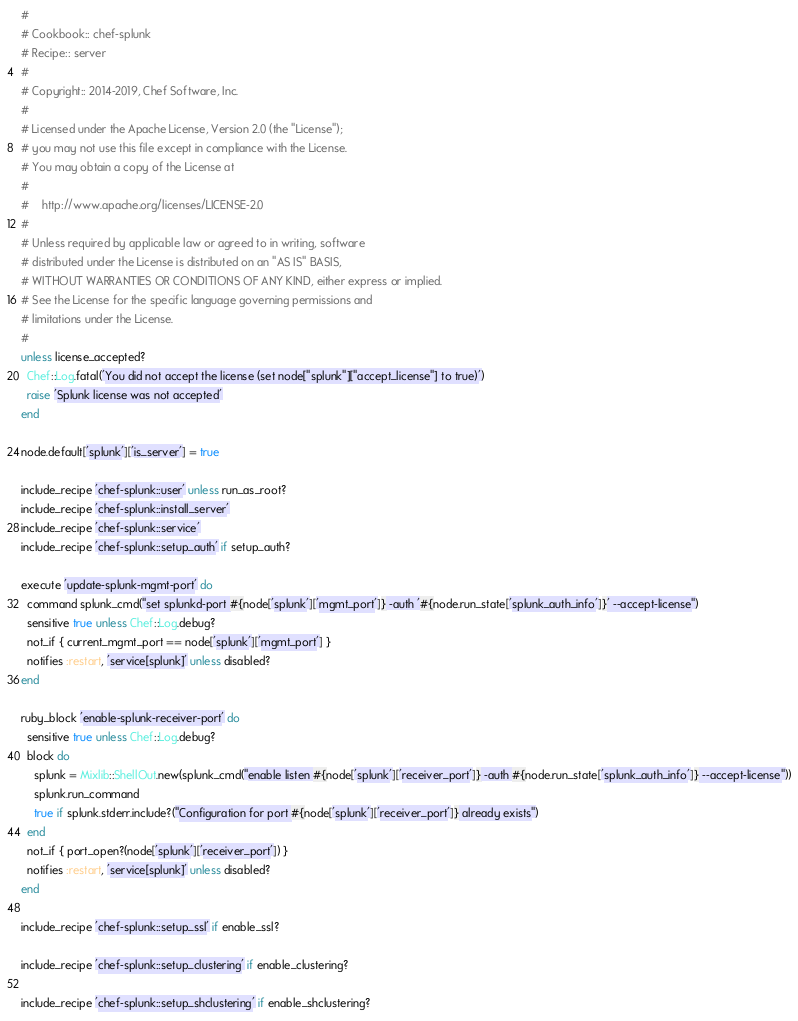Convert code to text. <code><loc_0><loc_0><loc_500><loc_500><_Ruby_>#
# Cookbook:: chef-splunk
# Recipe:: server
#
# Copyright:: 2014-2019, Chef Software, Inc.
#
# Licensed under the Apache License, Version 2.0 (the "License");
# you may not use this file except in compliance with the License.
# You may obtain a copy of the License at
#
#    http://www.apache.org/licenses/LICENSE-2.0
#
# Unless required by applicable law or agreed to in writing, software
# distributed under the License is distributed on an "AS IS" BASIS,
# WITHOUT WARRANTIES OR CONDITIONS OF ANY KIND, either express or implied.
# See the License for the specific language governing permissions and
# limitations under the License.
#
unless license_accepted?
  Chef::Log.fatal('You did not accept the license (set node["splunk"]["accept_license"] to true)')
  raise 'Splunk license was not accepted'
end

node.default['splunk']['is_server'] = true

include_recipe 'chef-splunk::user' unless run_as_root?
include_recipe 'chef-splunk::install_server'
include_recipe 'chef-splunk::service'
include_recipe 'chef-splunk::setup_auth' if setup_auth?

execute 'update-splunk-mgmt-port' do
  command splunk_cmd("set splunkd-port #{node['splunk']['mgmt_port']} -auth '#{node.run_state['splunk_auth_info']}' --accept-license")
  sensitive true unless Chef::Log.debug?
  not_if { current_mgmt_port == node['splunk']['mgmt_port'] }
  notifies :restart, 'service[splunk]' unless disabled?
end

ruby_block 'enable-splunk-receiver-port' do
  sensitive true unless Chef::Log.debug?
  block do
    splunk = Mixlib::ShellOut.new(splunk_cmd("enable listen #{node['splunk']['receiver_port']} -auth #{node.run_state['splunk_auth_info']} --accept-license"))
    splunk.run_command
    true if splunk.stderr.include?("Configuration for port #{node['splunk']['receiver_port']} already exists")
  end
  not_if { port_open?(node['splunk']['receiver_port']) }
  notifies :restart, 'service[splunk]' unless disabled?
end

include_recipe 'chef-splunk::setup_ssl' if enable_ssl?

include_recipe 'chef-splunk::setup_clustering' if enable_clustering?

include_recipe 'chef-splunk::setup_shclustering' if enable_shclustering?
</code> 